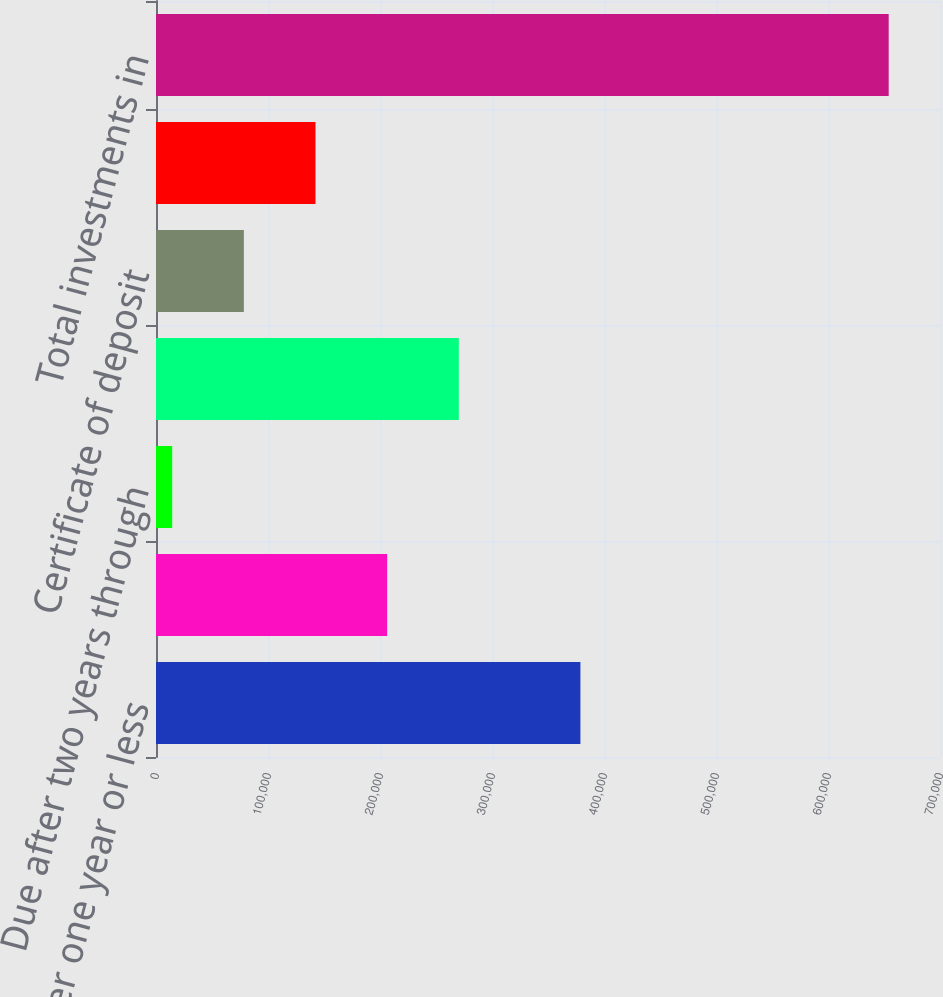Convert chart to OTSL. <chart><loc_0><loc_0><loc_500><loc_500><bar_chart><fcel>Due after one year or less<fcel>Due after one year through two<fcel>Due after two years through<fcel>Auction rate notes<fcel>Certificate of deposit<fcel>Asset/mortgage backed<fcel>Total investments in<nl><fcel>378929<fcel>206382<fcel>14465<fcel>270354<fcel>78437.2<fcel>142409<fcel>654187<nl></chart> 